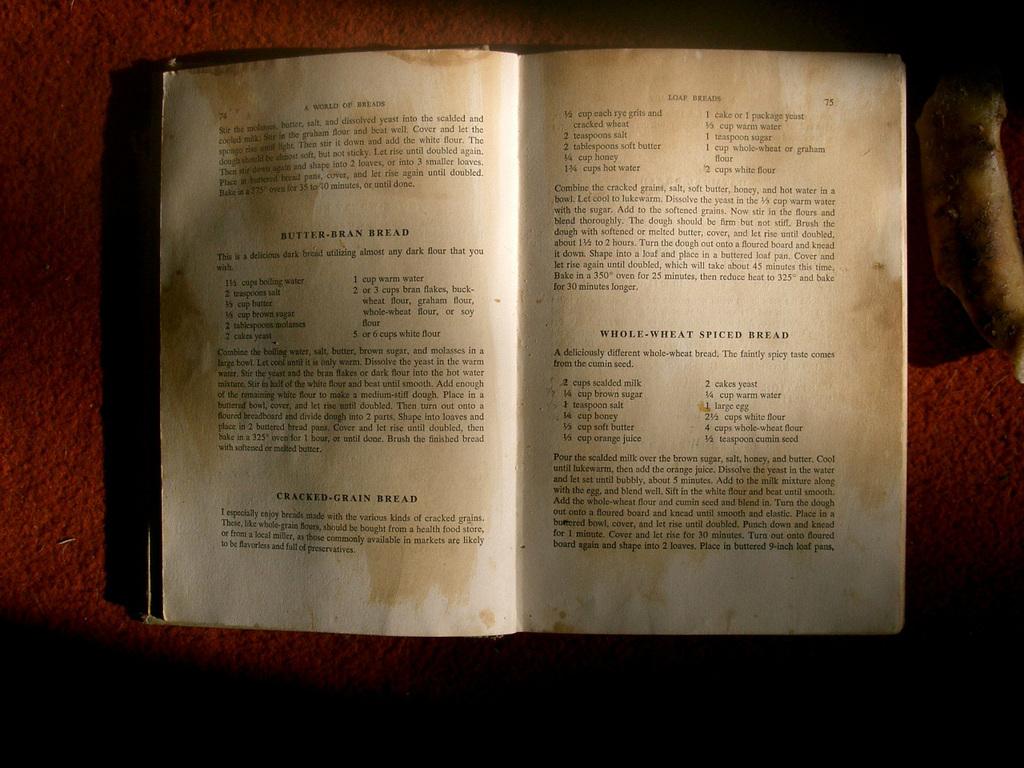What is one kind of bread mentioned on the right page?
Your answer should be compact. Unanswerable. What page number is the page on the right?
Your response must be concise. 75. 